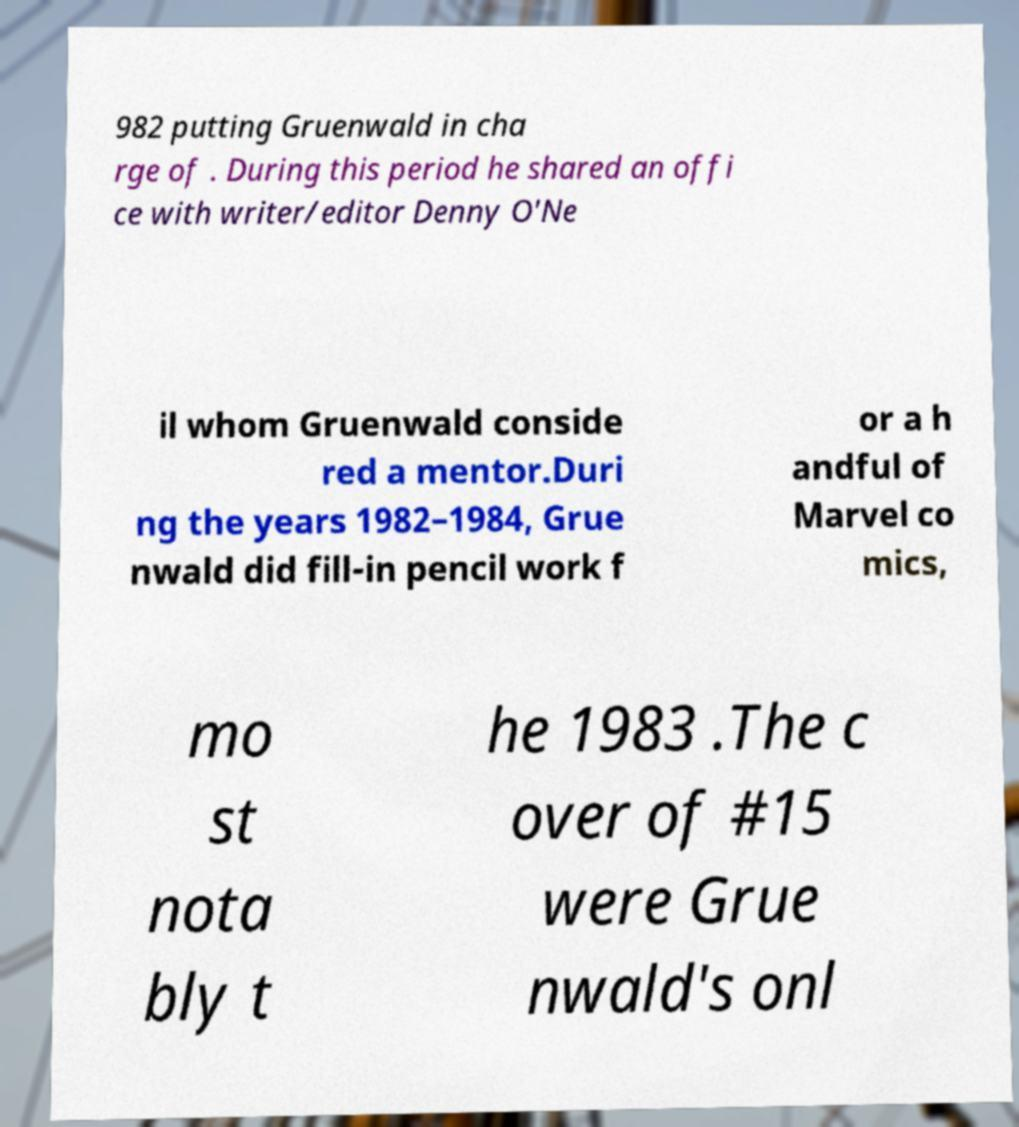I need the written content from this picture converted into text. Can you do that? 982 putting Gruenwald in cha rge of . During this period he shared an offi ce with writer/editor Denny O'Ne il whom Gruenwald conside red a mentor.Duri ng the years 1982–1984, Grue nwald did fill-in pencil work f or a h andful of Marvel co mics, mo st nota bly t he 1983 .The c over of #15 were Grue nwald's onl 